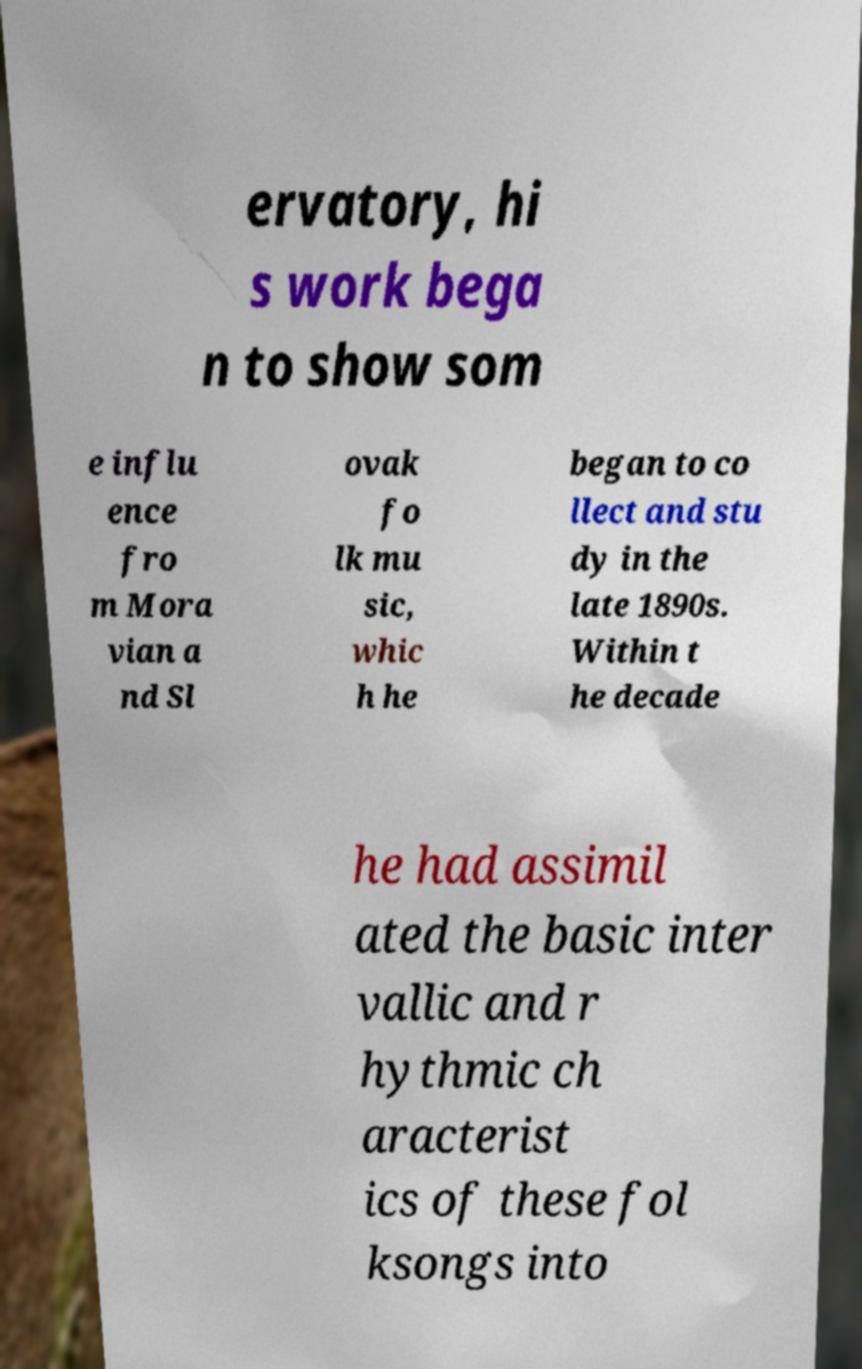Could you assist in decoding the text presented in this image and type it out clearly? ervatory, hi s work bega n to show som e influ ence fro m Mora vian a nd Sl ovak fo lk mu sic, whic h he began to co llect and stu dy in the late 1890s. Within t he decade he had assimil ated the basic inter vallic and r hythmic ch aracterist ics of these fol ksongs into 